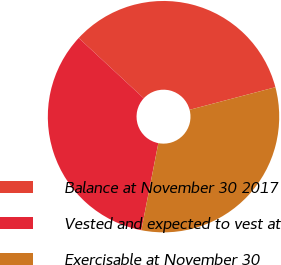<chart> <loc_0><loc_0><loc_500><loc_500><pie_chart><fcel>Balance at November 30 2017<fcel>Vested and expected to vest at<fcel>Exercisable at November 30<nl><fcel>34.0%<fcel>33.83%<fcel>32.17%<nl></chart> 